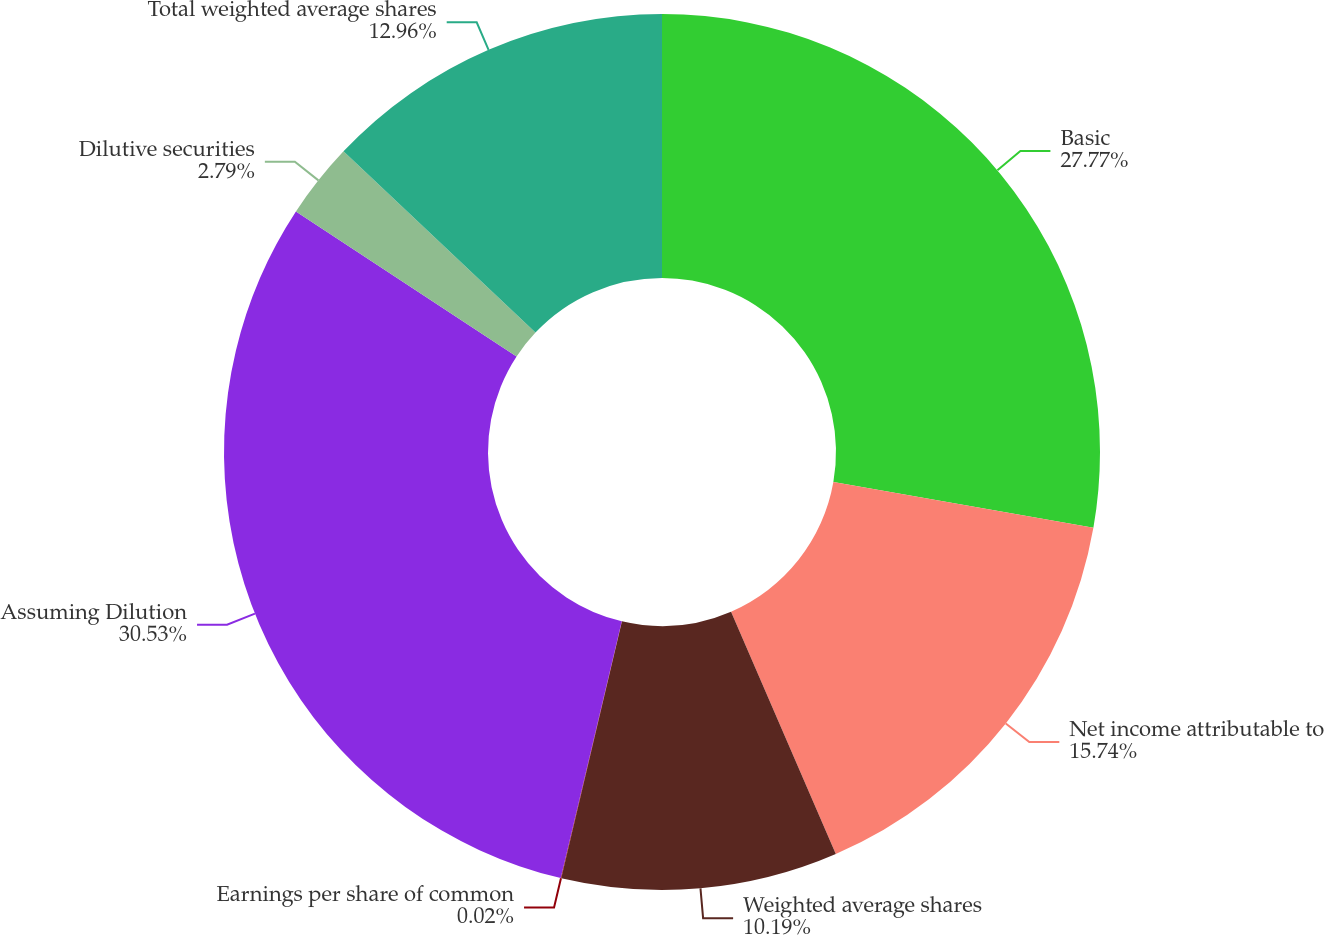<chart> <loc_0><loc_0><loc_500><loc_500><pie_chart><fcel>Basic<fcel>Net income attributable to<fcel>Weighted average shares<fcel>Earnings per share of common<fcel>Assuming Dilution<fcel>Dilutive securities<fcel>Total weighted average shares<nl><fcel>27.77%<fcel>15.74%<fcel>10.19%<fcel>0.02%<fcel>30.54%<fcel>2.79%<fcel>12.96%<nl></chart> 